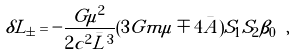<formula> <loc_0><loc_0><loc_500><loc_500>\delta L _ { \pm } = - \frac { G \mu ^ { 2 } } { 2 c ^ { 2 } \bar { L } ^ { 3 } } ( 3 G m \mu \mp 4 \bar { A } ) S _ { 1 } S _ { 2 } \beta _ { 0 } \ ,</formula> 